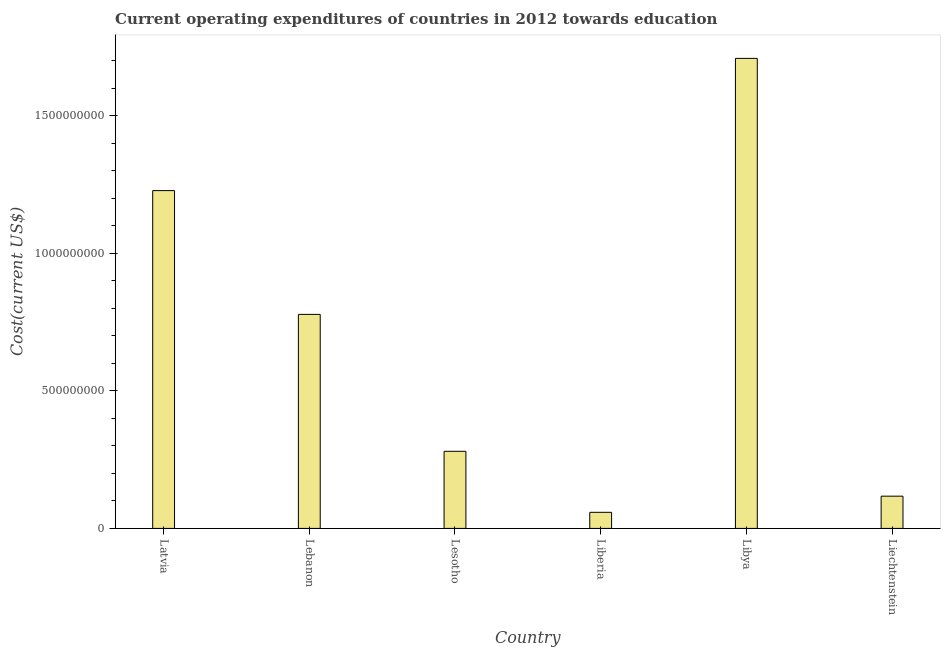Does the graph contain any zero values?
Make the answer very short. No. What is the title of the graph?
Offer a very short reply. Current operating expenditures of countries in 2012 towards education. What is the label or title of the Y-axis?
Ensure brevity in your answer.  Cost(current US$). What is the education expenditure in Libya?
Offer a terse response. 1.71e+09. Across all countries, what is the maximum education expenditure?
Give a very brief answer. 1.71e+09. Across all countries, what is the minimum education expenditure?
Ensure brevity in your answer.  5.85e+07. In which country was the education expenditure maximum?
Provide a short and direct response. Libya. In which country was the education expenditure minimum?
Offer a very short reply. Liberia. What is the sum of the education expenditure?
Make the answer very short. 4.17e+09. What is the difference between the education expenditure in Lesotho and Libya?
Your answer should be compact. -1.43e+09. What is the average education expenditure per country?
Make the answer very short. 6.95e+08. What is the median education expenditure?
Give a very brief answer. 5.29e+08. What is the ratio of the education expenditure in Lebanon to that in Lesotho?
Give a very brief answer. 2.78. Is the education expenditure in Lesotho less than that in Liechtenstein?
Your answer should be compact. No. Is the difference between the education expenditure in Latvia and Liechtenstein greater than the difference between any two countries?
Your answer should be compact. No. What is the difference between the highest and the second highest education expenditure?
Offer a very short reply. 4.81e+08. What is the difference between the highest and the lowest education expenditure?
Your response must be concise. 1.65e+09. In how many countries, is the education expenditure greater than the average education expenditure taken over all countries?
Your answer should be very brief. 3. How many bars are there?
Give a very brief answer. 6. Are all the bars in the graph horizontal?
Offer a terse response. No. How many countries are there in the graph?
Offer a very short reply. 6. What is the Cost(current US$) in Latvia?
Provide a short and direct response. 1.23e+09. What is the Cost(current US$) in Lebanon?
Your answer should be very brief. 7.78e+08. What is the Cost(current US$) of Lesotho?
Offer a very short reply. 2.80e+08. What is the Cost(current US$) of Liberia?
Provide a short and direct response. 5.85e+07. What is the Cost(current US$) in Libya?
Your answer should be very brief. 1.71e+09. What is the Cost(current US$) in Liechtenstein?
Provide a short and direct response. 1.17e+08. What is the difference between the Cost(current US$) in Latvia and Lebanon?
Keep it short and to the point. 4.50e+08. What is the difference between the Cost(current US$) in Latvia and Lesotho?
Offer a terse response. 9.48e+08. What is the difference between the Cost(current US$) in Latvia and Liberia?
Make the answer very short. 1.17e+09. What is the difference between the Cost(current US$) in Latvia and Libya?
Keep it short and to the point. -4.81e+08. What is the difference between the Cost(current US$) in Latvia and Liechtenstein?
Ensure brevity in your answer.  1.11e+09. What is the difference between the Cost(current US$) in Lebanon and Lesotho?
Offer a terse response. 4.98e+08. What is the difference between the Cost(current US$) in Lebanon and Liberia?
Your response must be concise. 7.20e+08. What is the difference between the Cost(current US$) in Lebanon and Libya?
Your answer should be very brief. -9.31e+08. What is the difference between the Cost(current US$) in Lebanon and Liechtenstein?
Make the answer very short. 6.61e+08. What is the difference between the Cost(current US$) in Lesotho and Liberia?
Offer a very short reply. 2.22e+08. What is the difference between the Cost(current US$) in Lesotho and Libya?
Give a very brief answer. -1.43e+09. What is the difference between the Cost(current US$) in Lesotho and Liechtenstein?
Offer a very short reply. 1.63e+08. What is the difference between the Cost(current US$) in Liberia and Libya?
Your response must be concise. -1.65e+09. What is the difference between the Cost(current US$) in Liberia and Liechtenstein?
Your answer should be compact. -5.87e+07. What is the difference between the Cost(current US$) in Libya and Liechtenstein?
Offer a very short reply. 1.59e+09. What is the ratio of the Cost(current US$) in Latvia to that in Lebanon?
Offer a very short reply. 1.58. What is the ratio of the Cost(current US$) in Latvia to that in Lesotho?
Offer a very short reply. 4.38. What is the ratio of the Cost(current US$) in Latvia to that in Liberia?
Give a very brief answer. 20.99. What is the ratio of the Cost(current US$) in Latvia to that in Libya?
Offer a very short reply. 0.72. What is the ratio of the Cost(current US$) in Latvia to that in Liechtenstein?
Offer a terse response. 10.48. What is the ratio of the Cost(current US$) in Lebanon to that in Lesotho?
Offer a very short reply. 2.78. What is the ratio of the Cost(current US$) in Lebanon to that in Liberia?
Provide a short and direct response. 13.3. What is the ratio of the Cost(current US$) in Lebanon to that in Libya?
Offer a terse response. 0.46. What is the ratio of the Cost(current US$) in Lebanon to that in Liechtenstein?
Your response must be concise. 6.64. What is the ratio of the Cost(current US$) in Lesotho to that in Liberia?
Your answer should be compact. 4.79. What is the ratio of the Cost(current US$) in Lesotho to that in Libya?
Provide a short and direct response. 0.16. What is the ratio of the Cost(current US$) in Lesotho to that in Liechtenstein?
Your answer should be very brief. 2.39. What is the ratio of the Cost(current US$) in Liberia to that in Libya?
Your answer should be compact. 0.03. What is the ratio of the Cost(current US$) in Liberia to that in Liechtenstein?
Your response must be concise. 0.5. What is the ratio of the Cost(current US$) in Libya to that in Liechtenstein?
Ensure brevity in your answer.  14.58. 